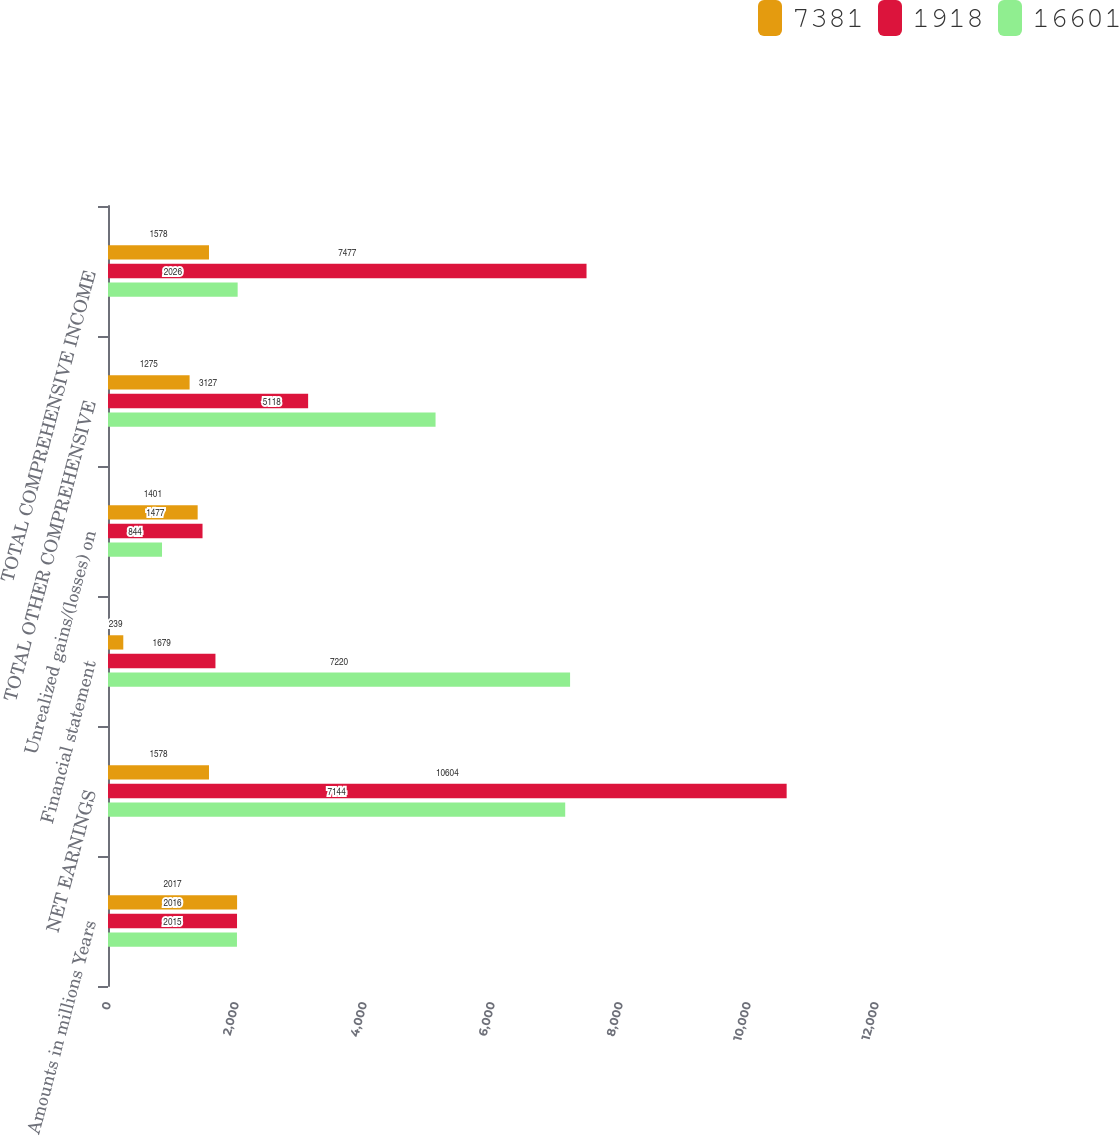<chart> <loc_0><loc_0><loc_500><loc_500><stacked_bar_chart><ecel><fcel>Amounts in millions Years<fcel>NET EARNINGS<fcel>Financial statement<fcel>Unrealized gains/(losses) on<fcel>TOTAL OTHER COMPREHENSIVE<fcel>TOTAL COMPREHENSIVE INCOME<nl><fcel>7381<fcel>2017<fcel>1578<fcel>239<fcel>1401<fcel>1275<fcel>1578<nl><fcel>1918<fcel>2016<fcel>10604<fcel>1679<fcel>1477<fcel>3127<fcel>7477<nl><fcel>16601<fcel>2015<fcel>7144<fcel>7220<fcel>844<fcel>5118<fcel>2026<nl></chart> 